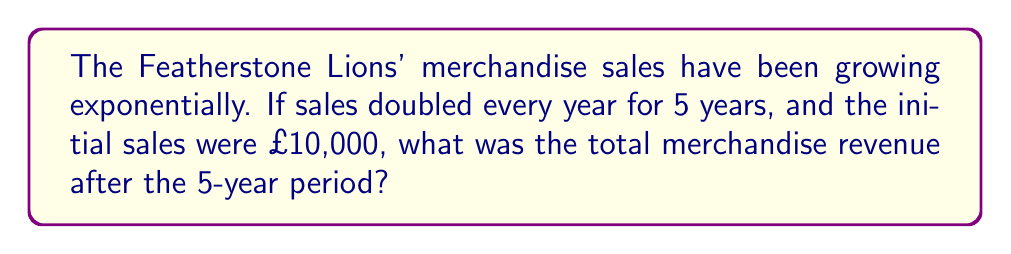What is the answer to this math problem? Let's approach this step-by-step:

1) The initial sales were £10,000.

2) Sales double every year, which means they increase by a factor of 2 each year.

3) This can be represented as an exponential function:
   $$ S = 10000 \times 2^n $$
   where $S$ is the sales after $n$ years.

4) We need to find the sales after 5 years, so we substitute $n = 5$:
   $$ S = 10000 \times 2^5 $$

5) Now, let's calculate $2^5$:
   $$ 2^5 = 2 \times 2 \times 2 \times 2 \times 2 = 32 $$

6) Substituting this back into our equation:
   $$ S = 10000 \times 32 = 320000 $$

Therefore, after 5 years, the Featherstone Lions' merchandise sales would be £320,000.
Answer: £320,000 